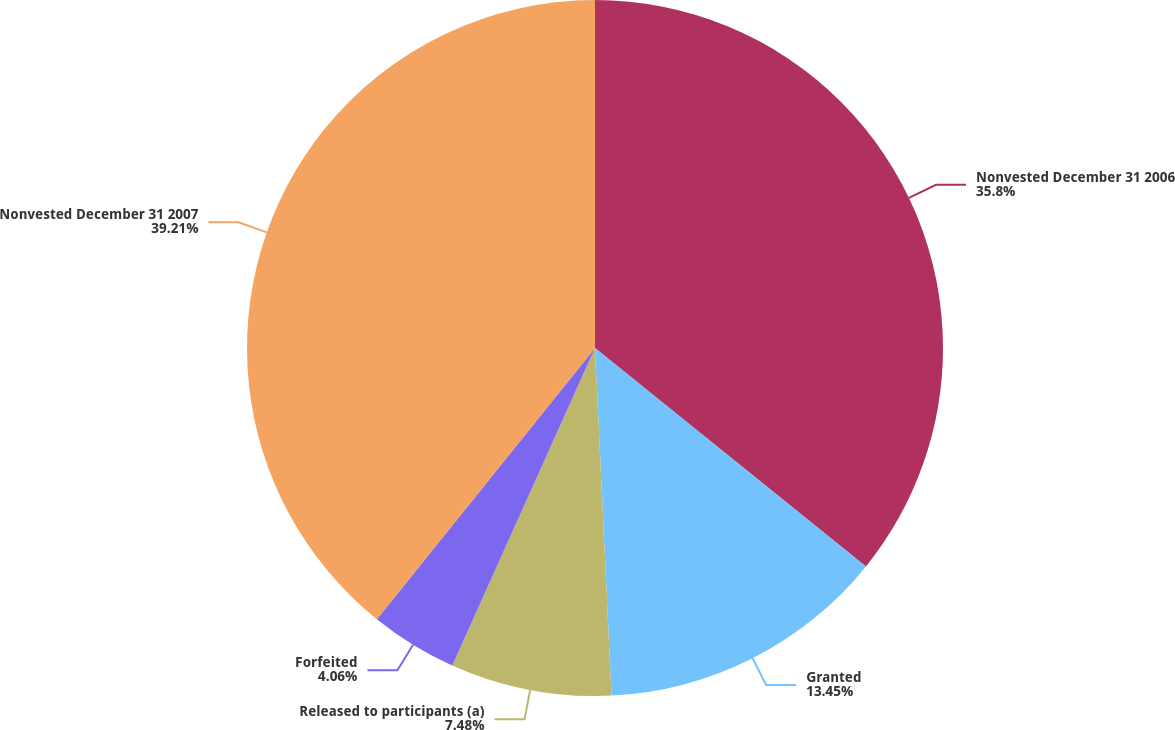Convert chart. <chart><loc_0><loc_0><loc_500><loc_500><pie_chart><fcel>Nonvested December 31 2006<fcel>Granted<fcel>Released to participants (a)<fcel>Forfeited<fcel>Nonvested December 31 2007<nl><fcel>35.8%<fcel>13.45%<fcel>7.48%<fcel>4.06%<fcel>39.22%<nl></chart> 